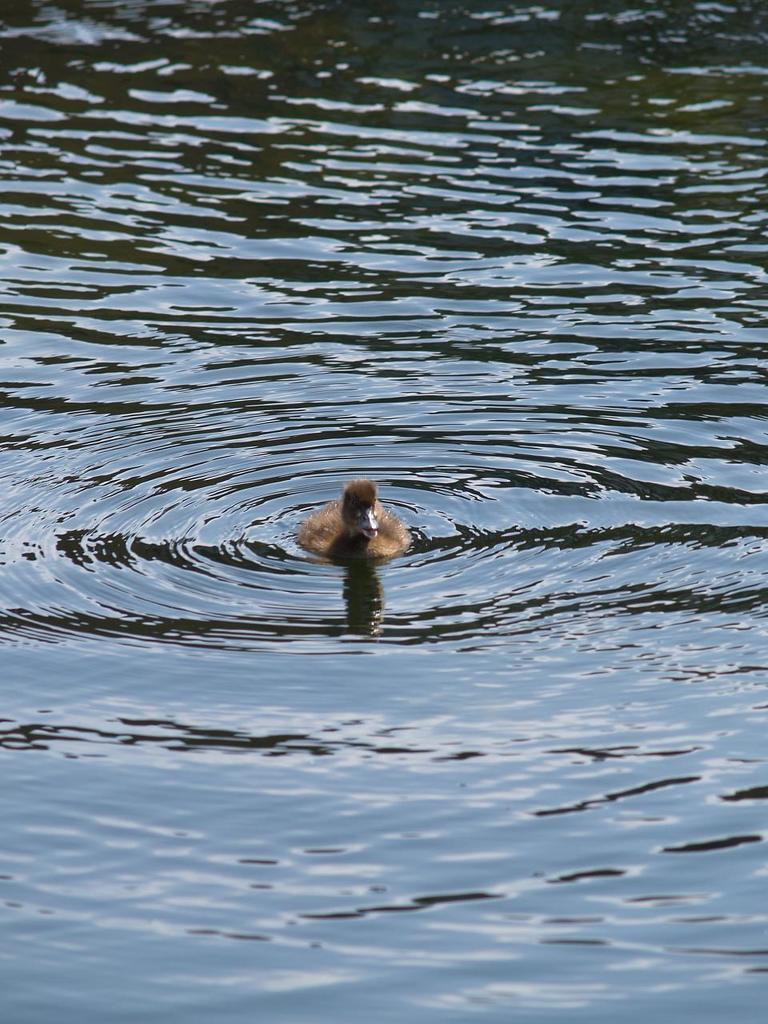Could you give a brief overview of what you see in this image? In this image I can see water and on it I can see a brown colour bird. 